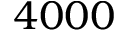<formula> <loc_0><loc_0><loc_500><loc_500>4 0 0 0</formula> 